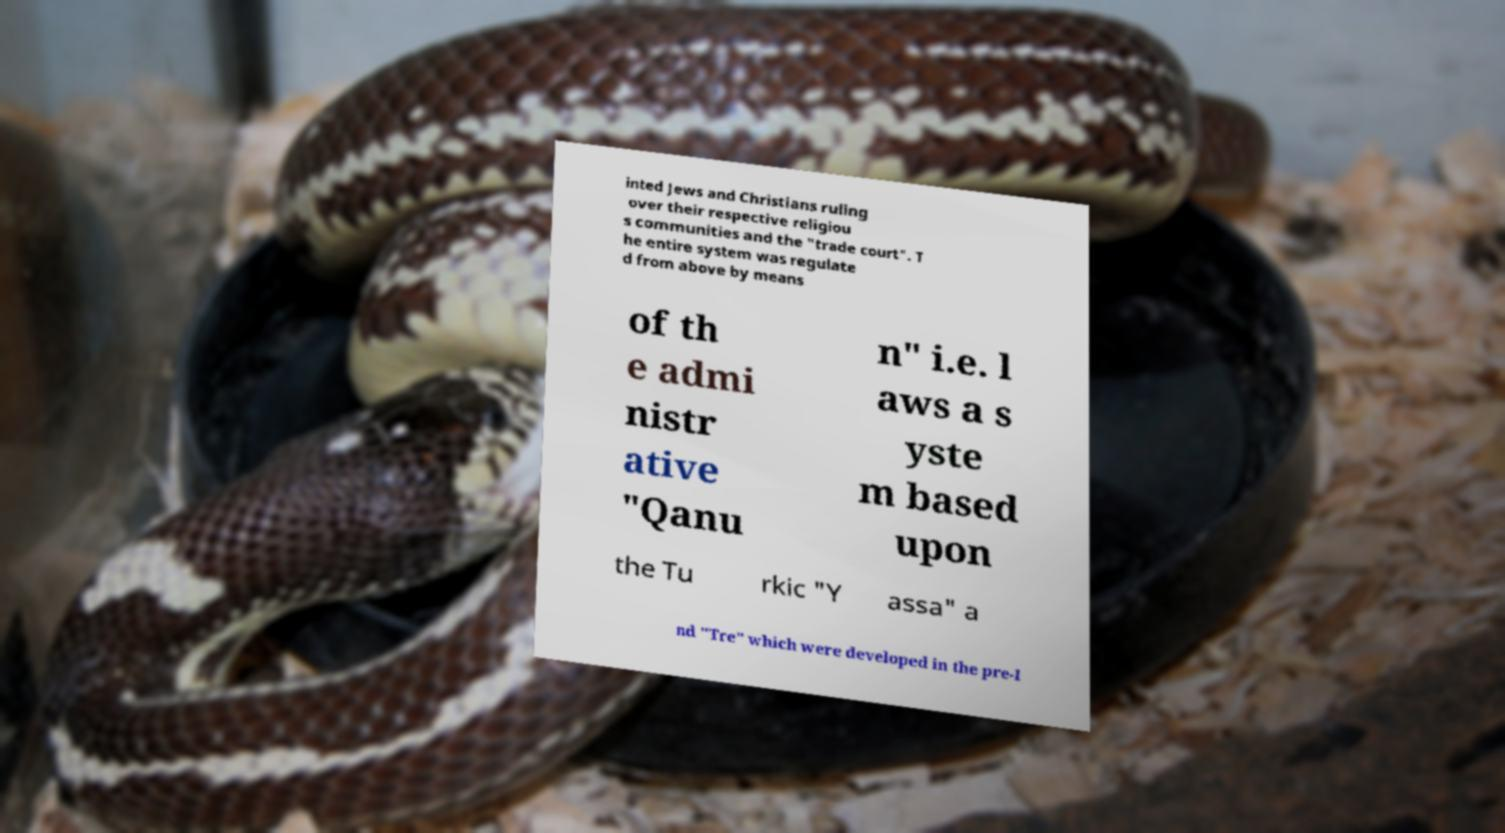Can you accurately transcribe the text from the provided image for me? inted Jews and Christians ruling over their respective religiou s communities and the "trade court". T he entire system was regulate d from above by means of th e admi nistr ative "Qanu n" i.e. l aws a s yste m based upon the Tu rkic "Y assa" a nd "Tre" which were developed in the pre-I 